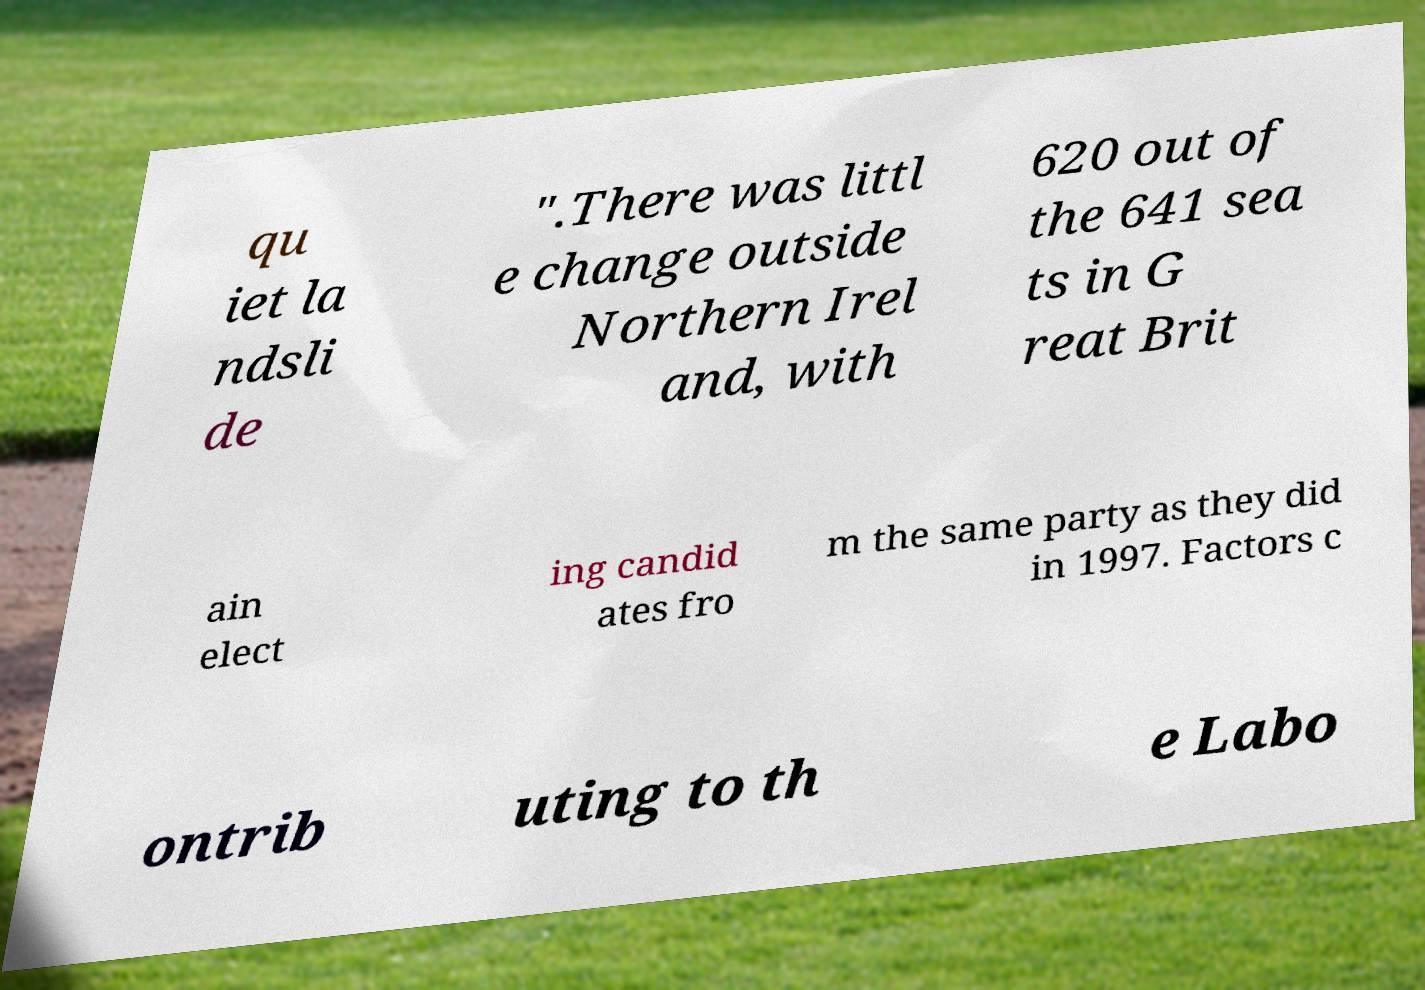Please identify and transcribe the text found in this image. qu iet la ndsli de ".There was littl e change outside Northern Irel and, with 620 out of the 641 sea ts in G reat Brit ain elect ing candid ates fro m the same party as they did in 1997. Factors c ontrib uting to th e Labo 